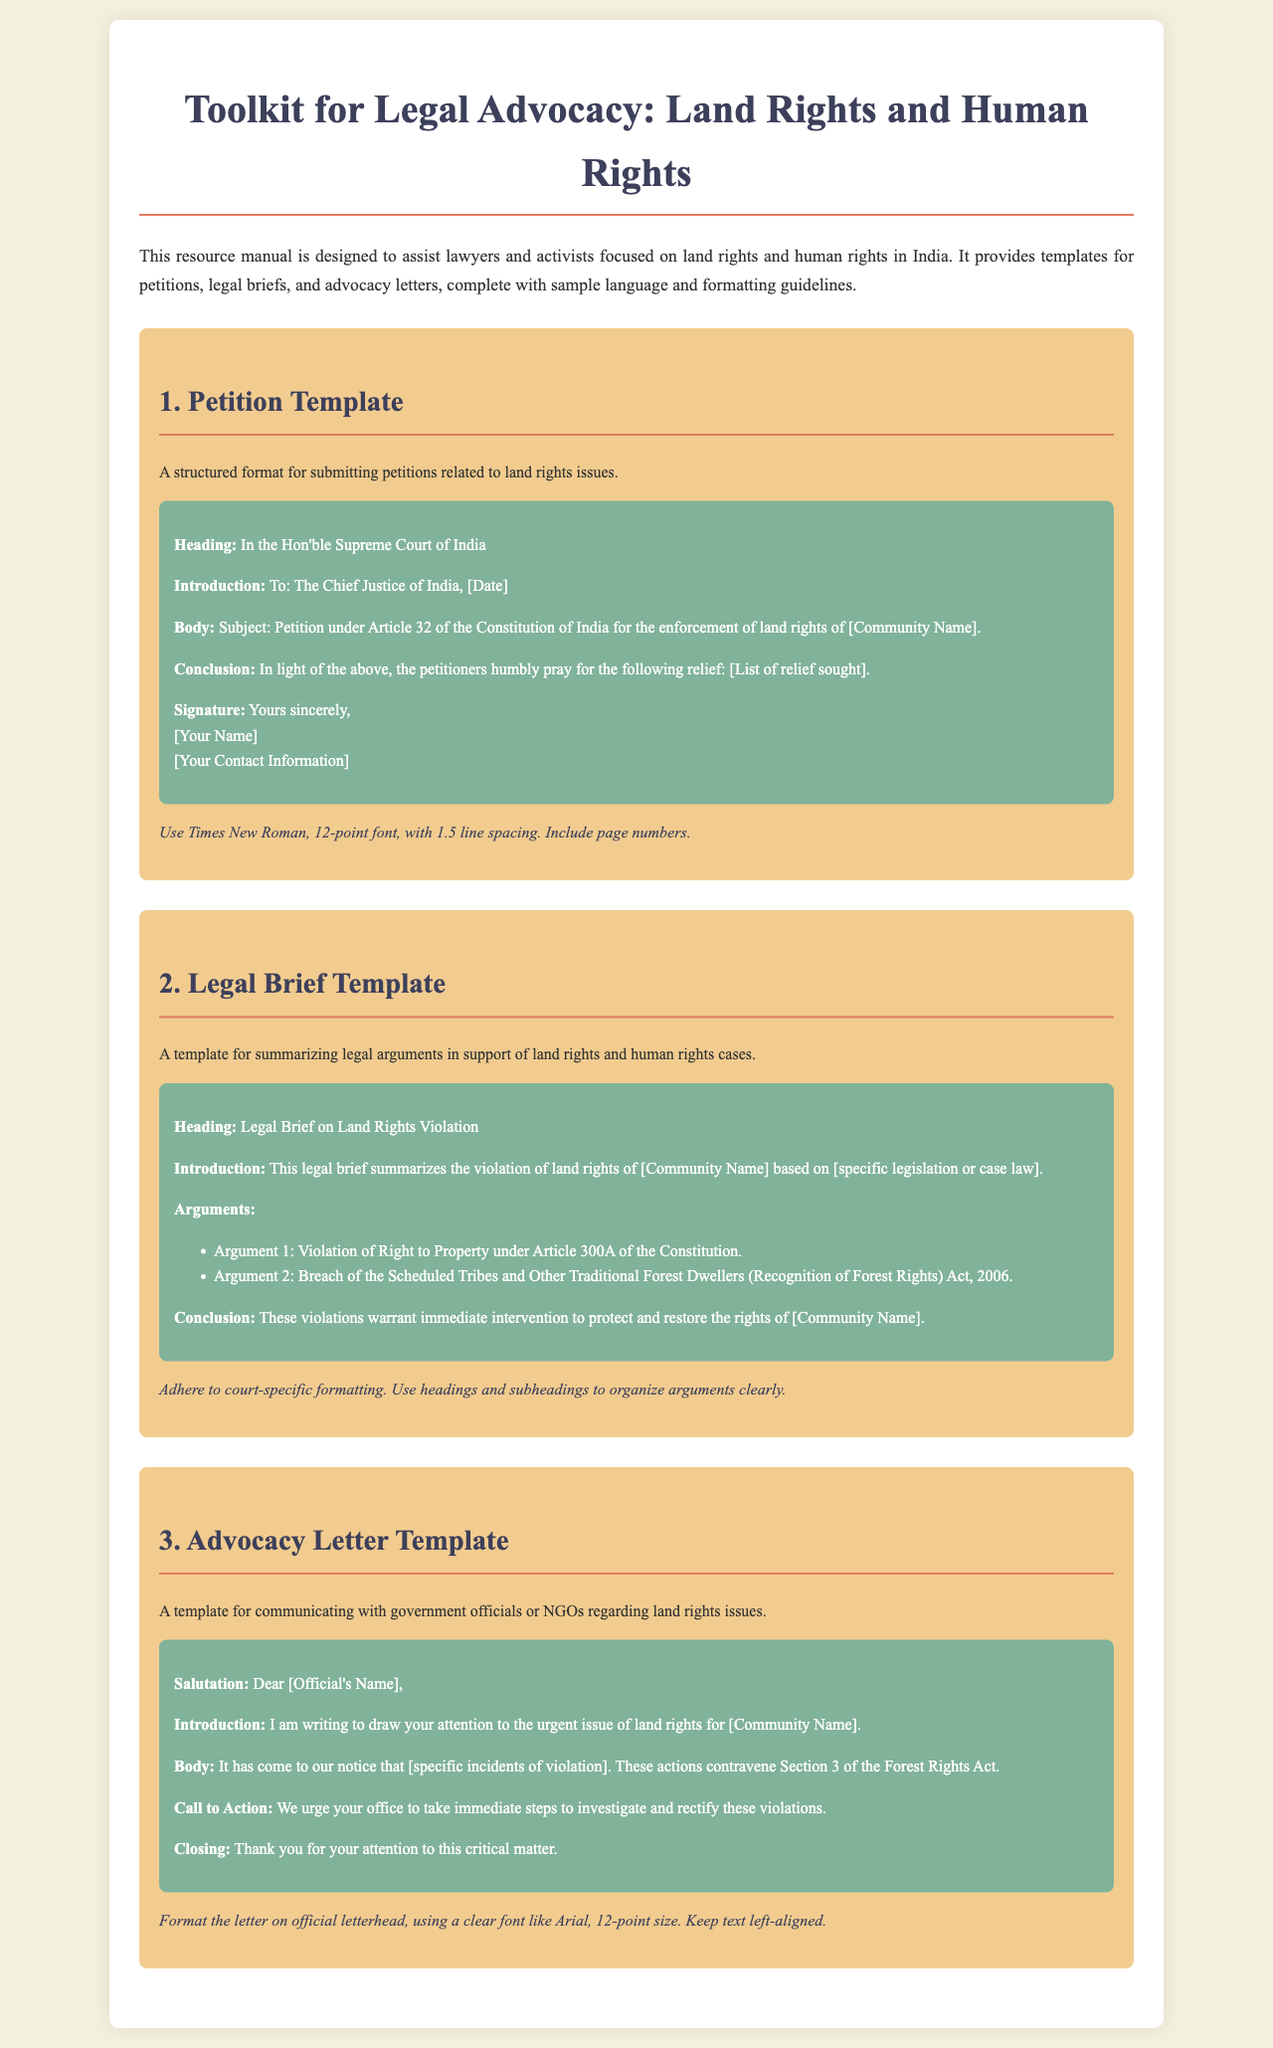What is the title of the document? The title of the document is mentioned at the top and is designed to introduce the content of the manual.
Answer: Toolkit for Legal Advocacy: Land Rights and Human Rights How many main sections are there in the document? The document organizes its content into three main sections, each dedicated to a specific template.
Answer: 3 What is included in the Petition Template? The Petition Template outlines a structured format with specific elements such as heading and conclusion for petitions.
Answer: Heading, Introduction, Body, Conclusion, Signature What kind of issues does the Advocacy Letter address? The Advocacy Letter is focused on communication with authorities regarding violations of specific rights.
Answer: Land rights issues What font and size should be used in the Petition Template? The formatting guidelines specify details about the font and size used in official documents.
Answer: Times New Roman, 12-point font What is the purpose of the Legal Brief Template? The Legal Brief Template serves to summarize legal arguments to support specific cases.
Answer: Summarizing legal arguments What action is urged in the Advocacy Letter? The Advocacy Letter calls for urgent steps to address and rectify specific incidents.
Answer: Investigate and rectify violations What specific legislation is referenced in the Legal Brief? The document mentions important legislative acts relevant to land rights violations.
Answer: Scheduled Tribes and Other Traditional Forest Dwellers (Recognition of Forest Rights) Act, 2006 What is the ideal closing for the Advocacy Letter? The closing of the Advocacy Letter is meant to express gratitude and reinforce the request for action.
Answer: Thank you for your attention to this critical matter 